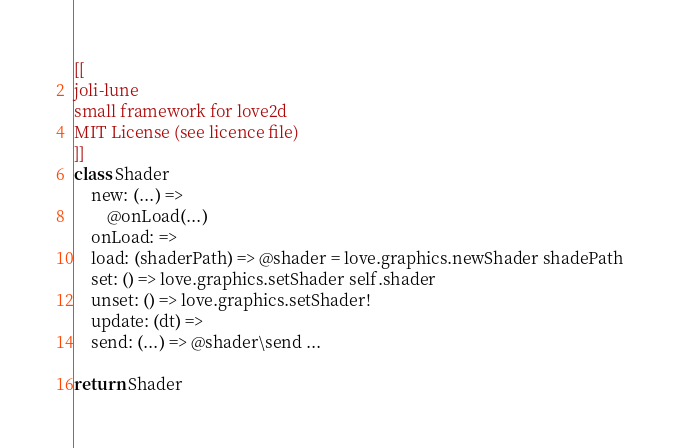<code> <loc_0><loc_0><loc_500><loc_500><_MoonScript_>[[
joli-lune
small framework for love2d
MIT License (see licence file)
]]
class Shader
	new: (...) =>
		@onLoad(...)
	onLoad: =>
	load: (shaderPath) => @shader = love.graphics.newShader shadePath
	set: () => love.graphics.setShader self.shader 
	unset: () => love.graphics.setShader!
	update: (dt) =>
	send: (...) => @shader\send ...

return Shader</code> 